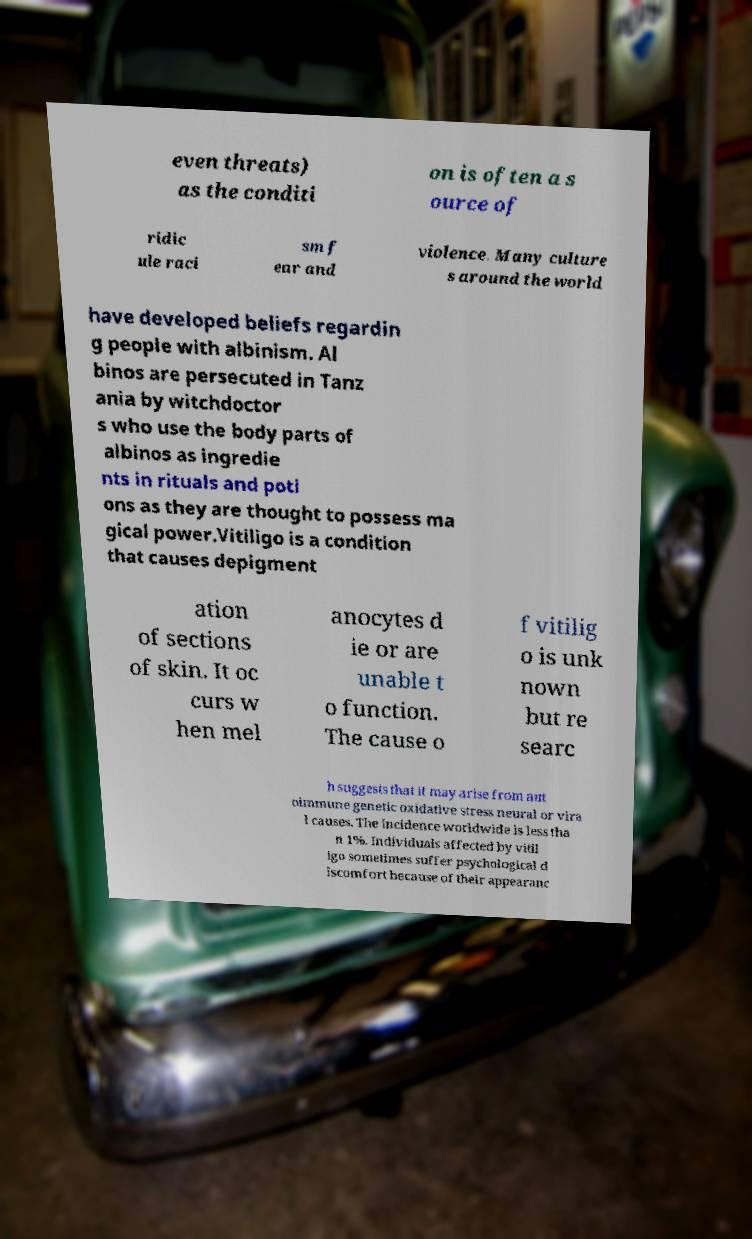Please read and relay the text visible in this image. What does it say? even threats) as the conditi on is often a s ource of ridic ule raci sm f ear and violence. Many culture s around the world have developed beliefs regardin g people with albinism. Al binos are persecuted in Tanz ania by witchdoctor s who use the body parts of albinos as ingredie nts in rituals and poti ons as they are thought to possess ma gical power.Vitiligo is a condition that causes depigment ation of sections of skin. It oc curs w hen mel anocytes d ie or are unable t o function. The cause o f vitilig o is unk nown but re searc h suggests that it may arise from aut oimmune genetic oxidative stress neural or vira l causes. The incidence worldwide is less tha n 1%. Individuals affected by vitil igo sometimes suffer psychological d iscomfort because of their appearanc 